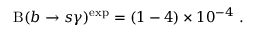<formula> <loc_0><loc_0><loc_500><loc_500>B ( b \to s \gamma ) ^ { e x p } = ( 1 - 4 ) \times 1 0 ^ { - 4 } \ .</formula> 